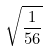Convert formula to latex. <formula><loc_0><loc_0><loc_500><loc_500>\sqrt { \frac { 1 } { 5 6 } }</formula> 